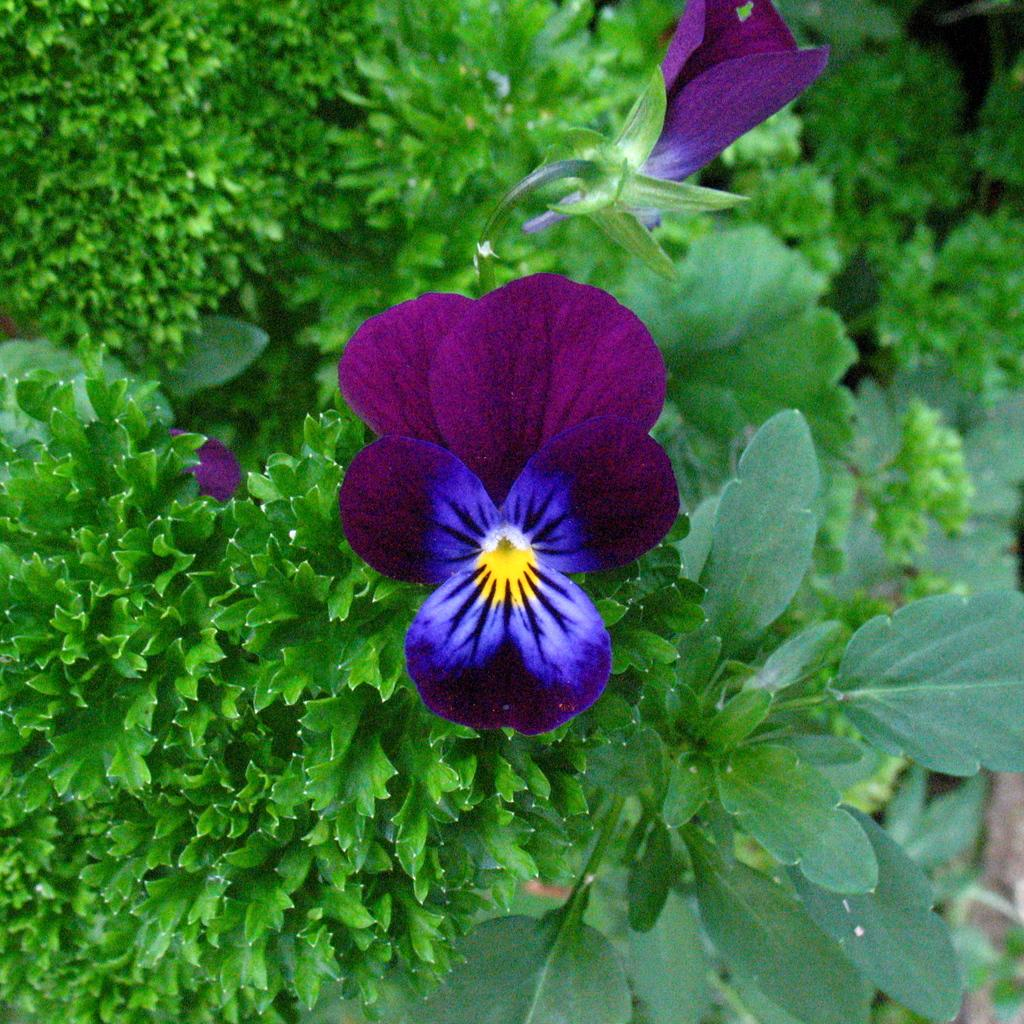What color are the flowers on the plant in the image? The flowers on the plant are violet in color. What can be seen in the background of the image? The background of the image is green. What flavor of ice cream do the cats in the image prefer? There are no cats or ice cream present in the image, so it is not possible to determine their flavor preferences. 